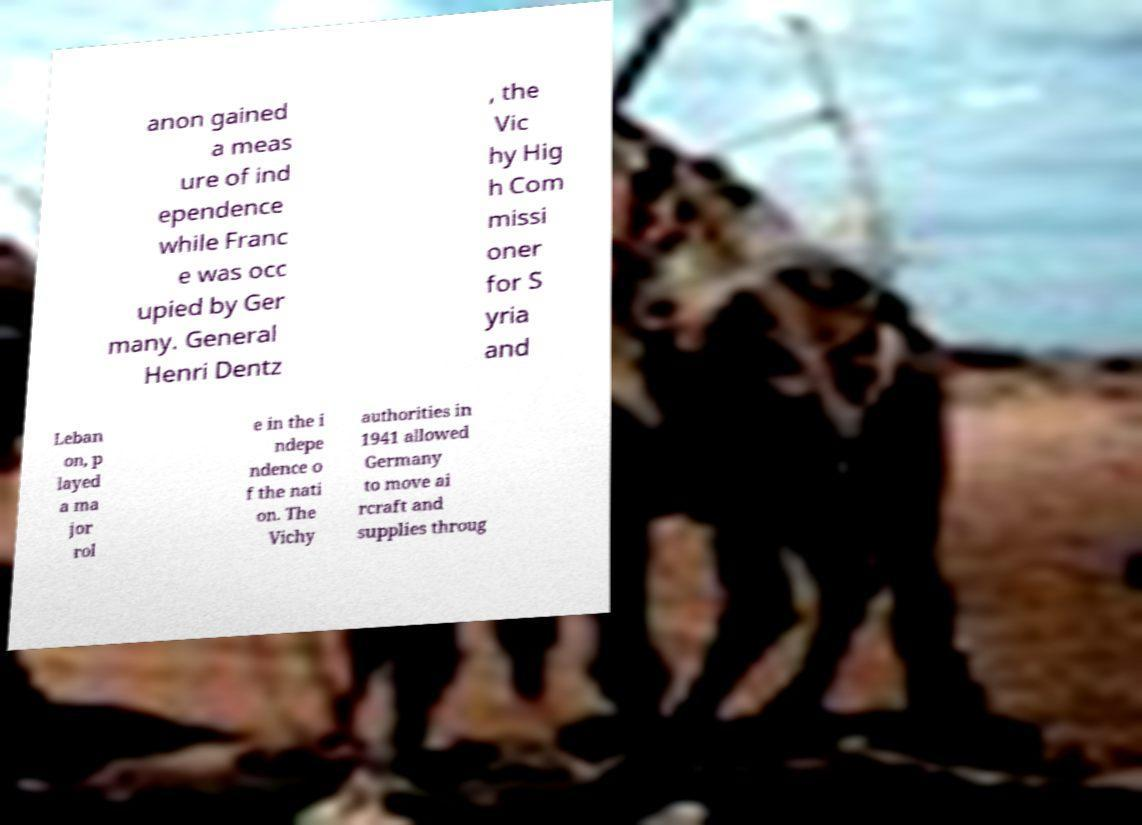I need the written content from this picture converted into text. Can you do that? anon gained a meas ure of ind ependence while Franc e was occ upied by Ger many. General Henri Dentz , the Vic hy Hig h Com missi oner for S yria and Leban on, p layed a ma jor rol e in the i ndepe ndence o f the nati on. The Vichy authorities in 1941 allowed Germany to move ai rcraft and supplies throug 